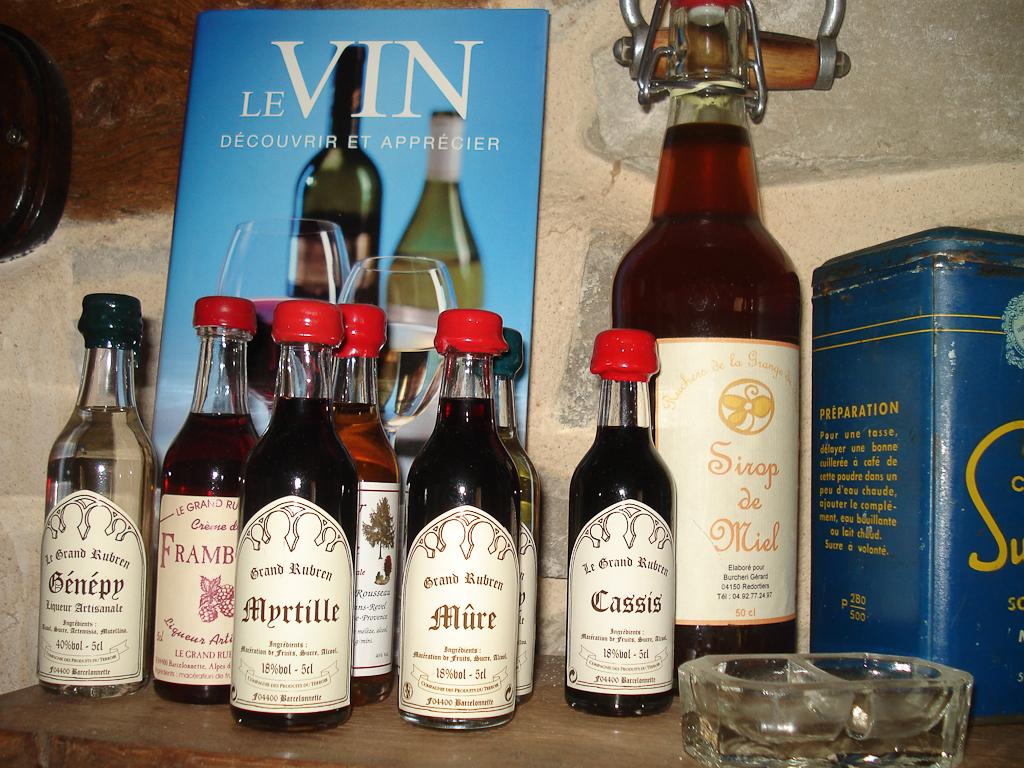What is the brand of alcohol shown?
Make the answer very short. Grand rubren. What is the top word of the yellow words?
Give a very brief answer. Sirop. 